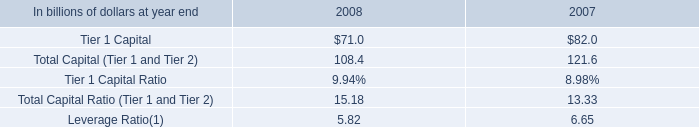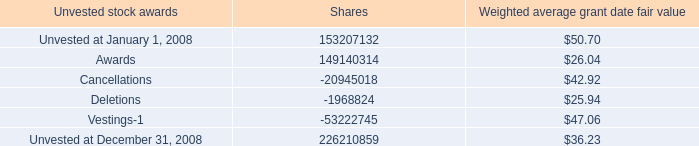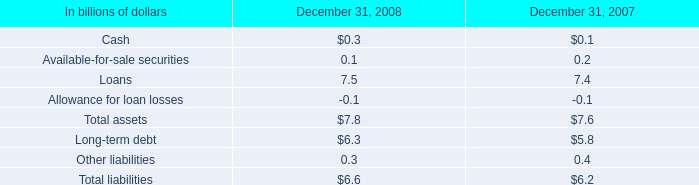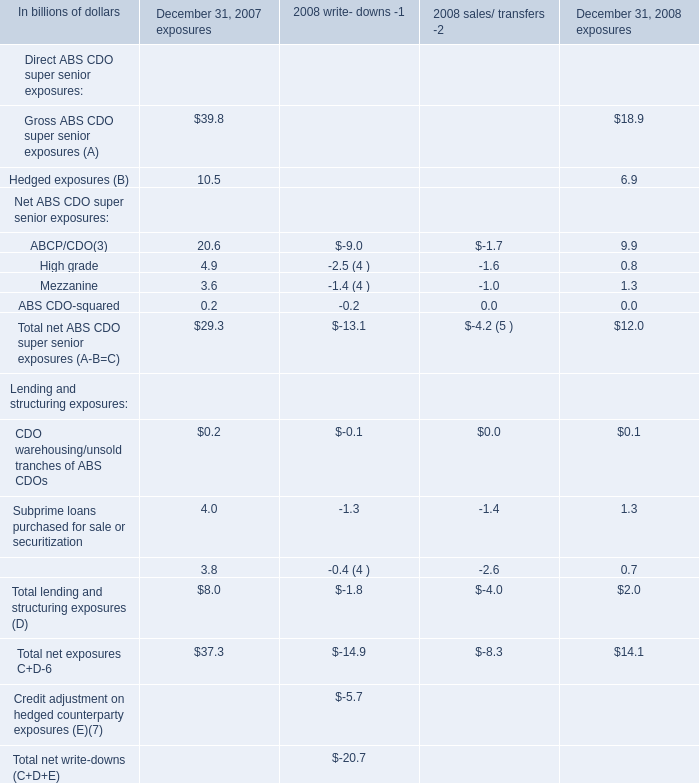as of 2008 what was annual cost is expected to be recognized of the total unrecognized compensation cost related to unvested stock awards net of the forfeiture provision in billions\\n 
Computations: (3.3 / 2.6)
Answer: 1.26923. 